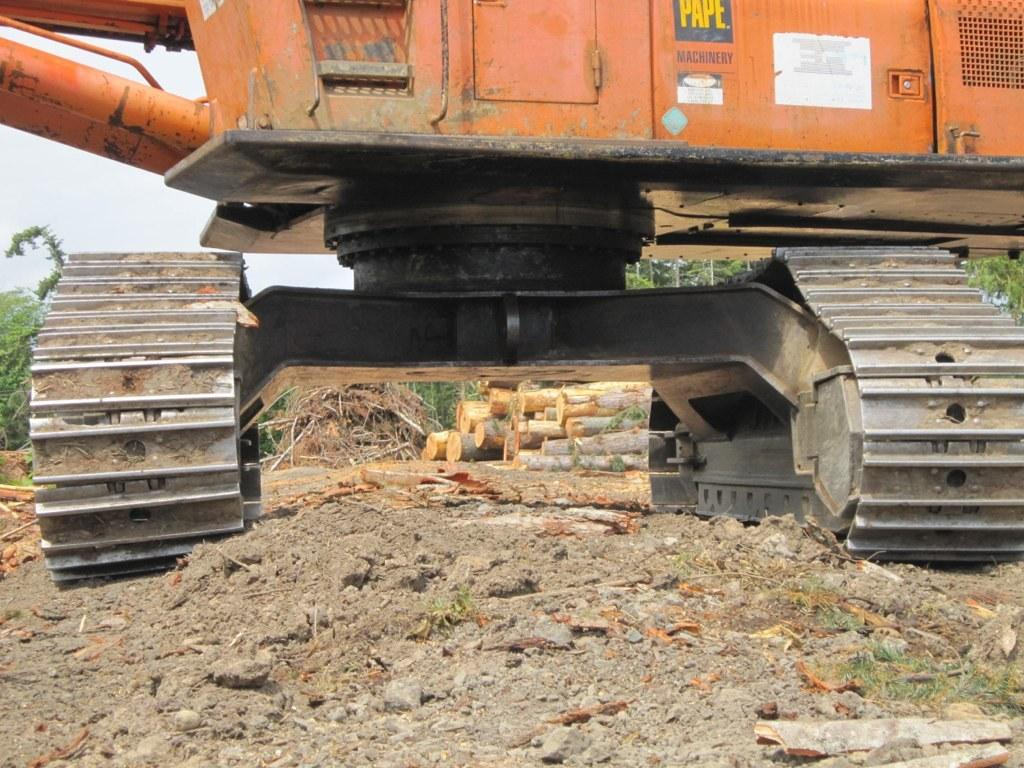What is the main subject in the middle of the image? There is a JCB in the middle of the image. What can be seen at the back side of the image? There are logs and trees at the back side of the image. What is visible on the left side of the image? The sky is visible on the left side of the image. Where is the baby sitting in the image? There is no baby present in the image. What type of achievement is the achiever holding in the image? There is no achiever or achievement present in the image. 